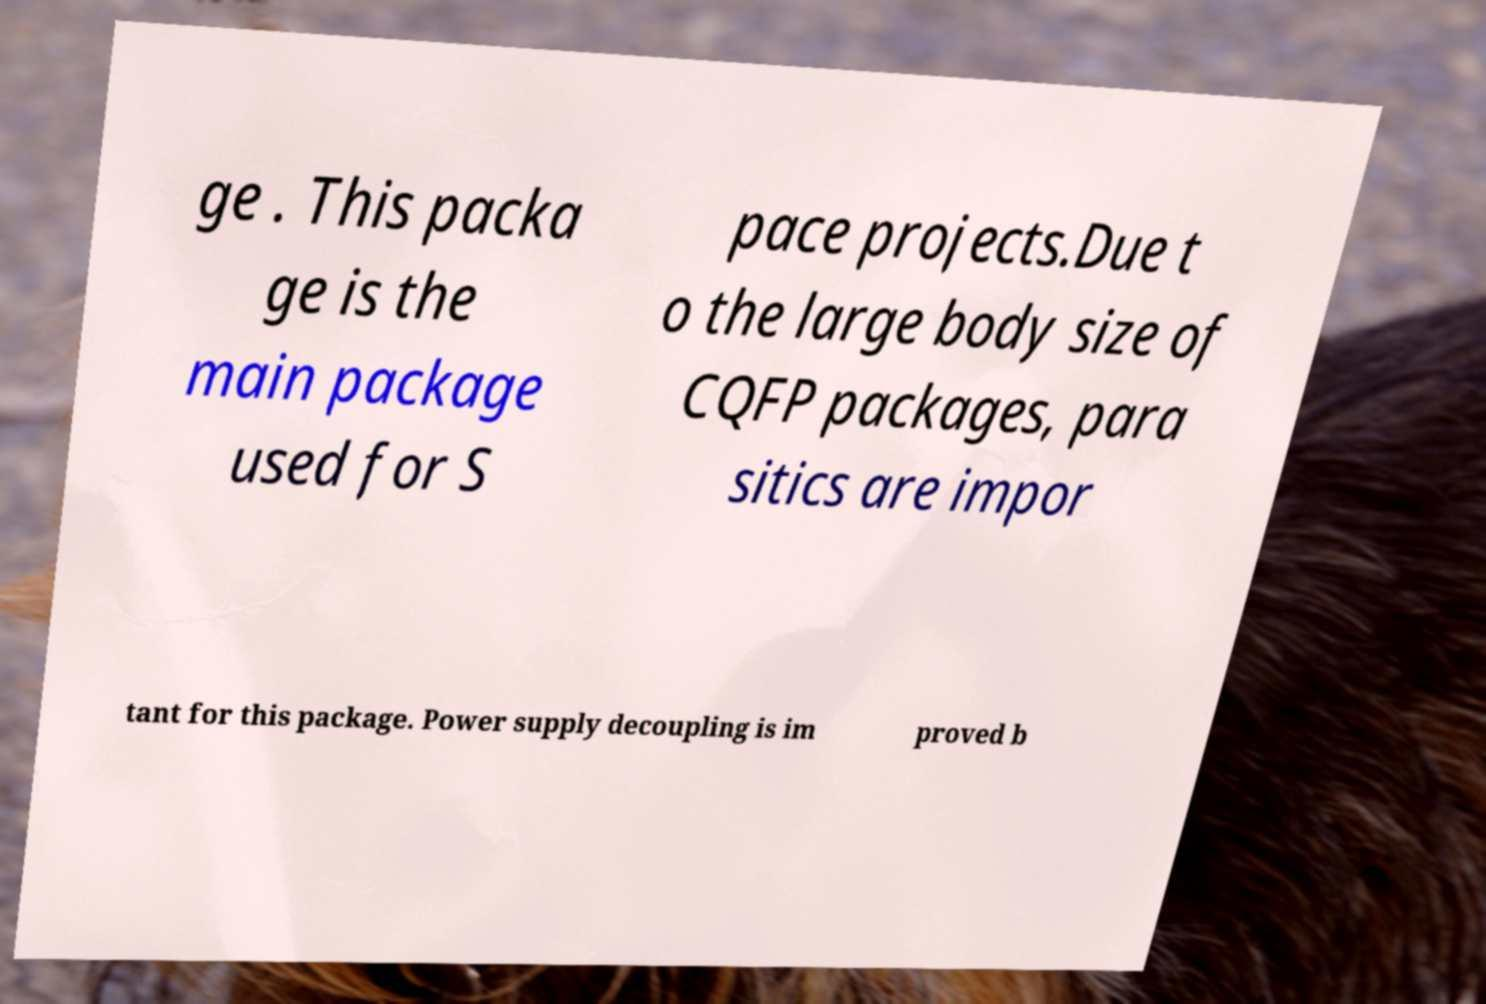Can you accurately transcribe the text from the provided image for me? ge . This packa ge is the main package used for S pace projects.Due t o the large body size of CQFP packages, para sitics are impor tant for this package. Power supply decoupling is im proved b 